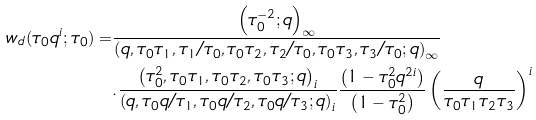<formula> <loc_0><loc_0><loc_500><loc_500>w _ { d } ( \tau _ { 0 } q ^ { i } ; \tau _ { 0 } ) = & \frac { \left ( \tau _ { 0 } ^ { - 2 } ; q \right ) _ { \infty } } { \left ( q , \tau _ { 0 } \tau _ { 1 } , \tau _ { 1 } / \tau _ { 0 } , \tau _ { 0 } \tau _ { 2 } , \tau _ { 2 } / \tau _ { 0 } , \tau _ { 0 } \tau _ { 3 } , \tau _ { 3 } / \tau _ { 0 } ; q \right ) _ { \infty } } \\ & . \frac { \left ( \tau _ { 0 } ^ { 2 } , \tau _ { 0 } \tau _ { 1 } , \tau _ { 0 } \tau _ { 2 } , \tau _ { 0 } \tau _ { 3 } ; q \right ) _ { i } } { \left ( q , \tau _ { 0 } q / \tau _ { 1 } , \tau _ { 0 } q / \tau _ { 2 } , \tau _ { 0 } q / \tau _ { 3 } ; q \right ) _ { i } } \frac { \left ( 1 - \tau _ { 0 } ^ { 2 } q ^ { 2 i } \right ) } { \left ( 1 - \tau _ { 0 } ^ { 2 } \right ) } \left ( \frac { q } { \tau _ { 0 } \tau _ { 1 } \tau _ { 2 } \tau _ { 3 } } \right ) ^ { i } \\</formula> 